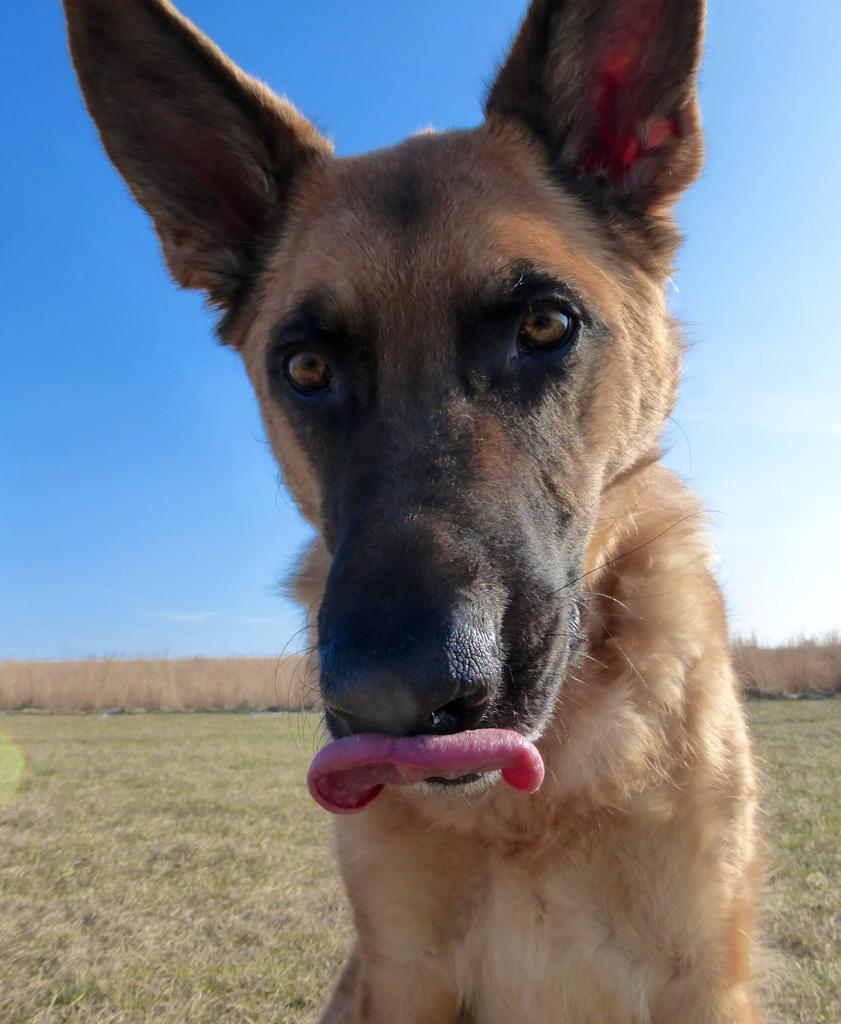What type of animal is in the image? There is a brown dog in the image. What position is the dog in? The dog is sitting in the front. What is the dog's focus in the image? The dog is looking at the camera. What type of ground is visible in the image? There is dry grass visible in the image. How would you describe the weather based on the sky in the image? The sky is blue and clear in the image, suggesting good weather. Can you see the guitar that the dog is playing in the image? There is no guitar present in the image, and the dog is not playing any instrument. 